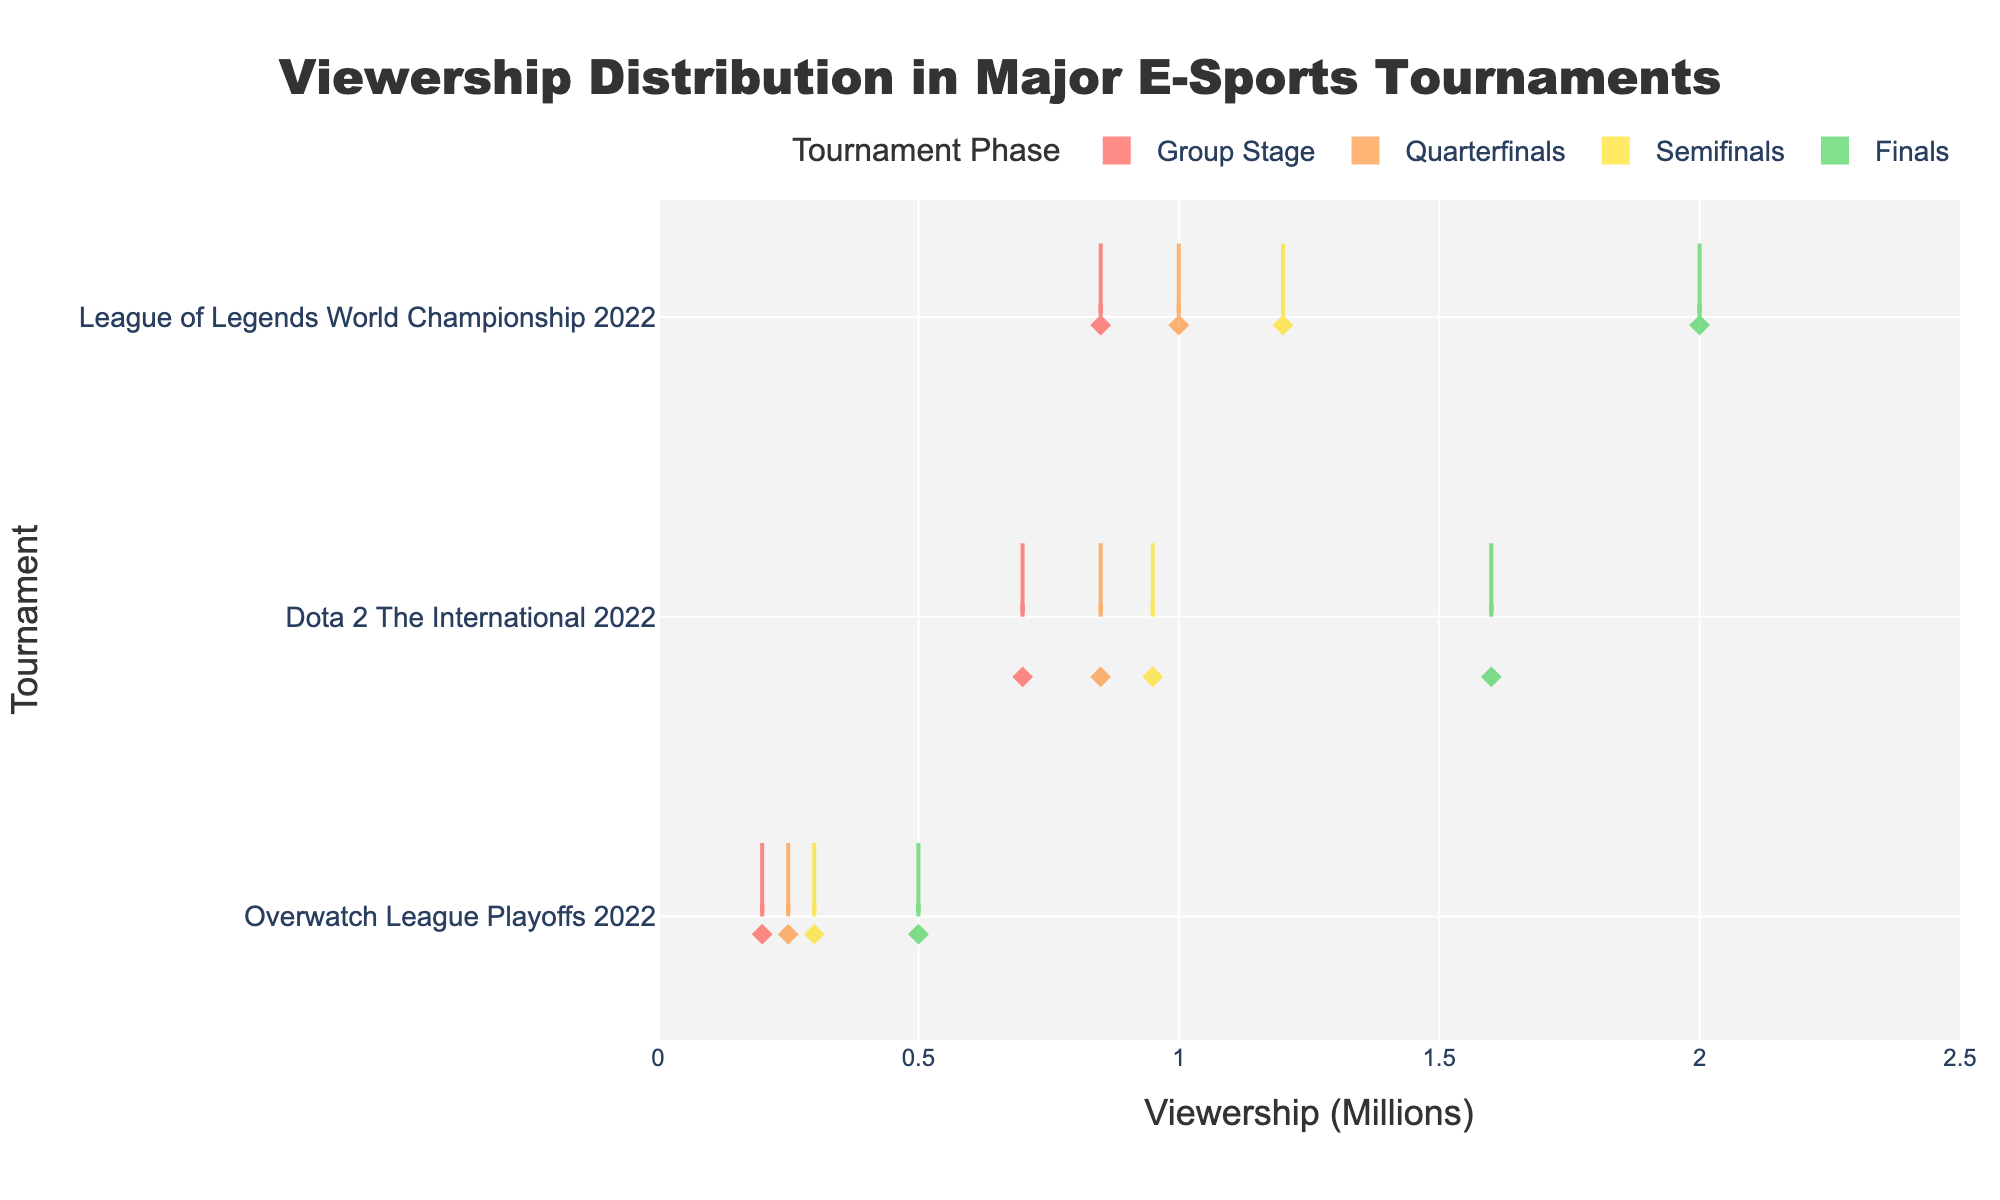What is the title of the chart? The title is located at the top of the chart, and it usually provides a summary of what the chart represents. Here, it is prominently displayed.
Answer: Viewership Distribution in Major E-Sports Tournaments Which phase has the highest viewership for the League of Legends World Championship 2022? By locating the "League of Legends World Championship 2022" data points and comparing them across different phases, we see the highest point at the Finals phase.
Answer: Finals How many data points are shown for each phase? Each phase appears once in the legend, and by counting the number of boxes or data points aligned horizontally for each phase, we can determine this.
Answer: Three What is the range of viewership numbers for the Finals across all tournaments? By observing the horizontal span of the violin plots for the Finals phase, we determine the minimum and maximum values, converted from millions to millions.
Answer: 0.5 to 2.0 million What tournament has the lowest viewership in the Semifinals phase? Examine the Semifinals phase for the shortest extent horizontally in the violin plot, noting the corresponding tournament.
Answer: Overwatch League Playoffs 2022 Compare the median viewership for Dota 2 The International 2022 between the Group Stage and the Finals. Identify and note the median lines within the violin plots for the given tournament in both Group Stage and Finals, and compare them.
Answer: 0.7 million (Group Stage), 1.6 million (Finals) Is the viewership trend increasing or decreasing from Group Stage to Finals for the Overwatch League Playoffs 2022? Check the Overwatch League Playoffs 2022 data across all phases and observe the trend of positions across the violin plots from Group Stage to Finals.
Answer: Increasing What is the mean viewership for the Quarterfinals phase for all tournaments combined? Sum the viewership numbers for all tournaments in the Quarterfinals and divide by the number of data points (three). This requires calculating each violin plot's central line or average value.
Answer: ~0.7 million Which tournament phase appears to have the most variation in viewership? Identify the phase with the widest spread for its corresponding violin plot, displaying the most variation.
Answer: Finals 